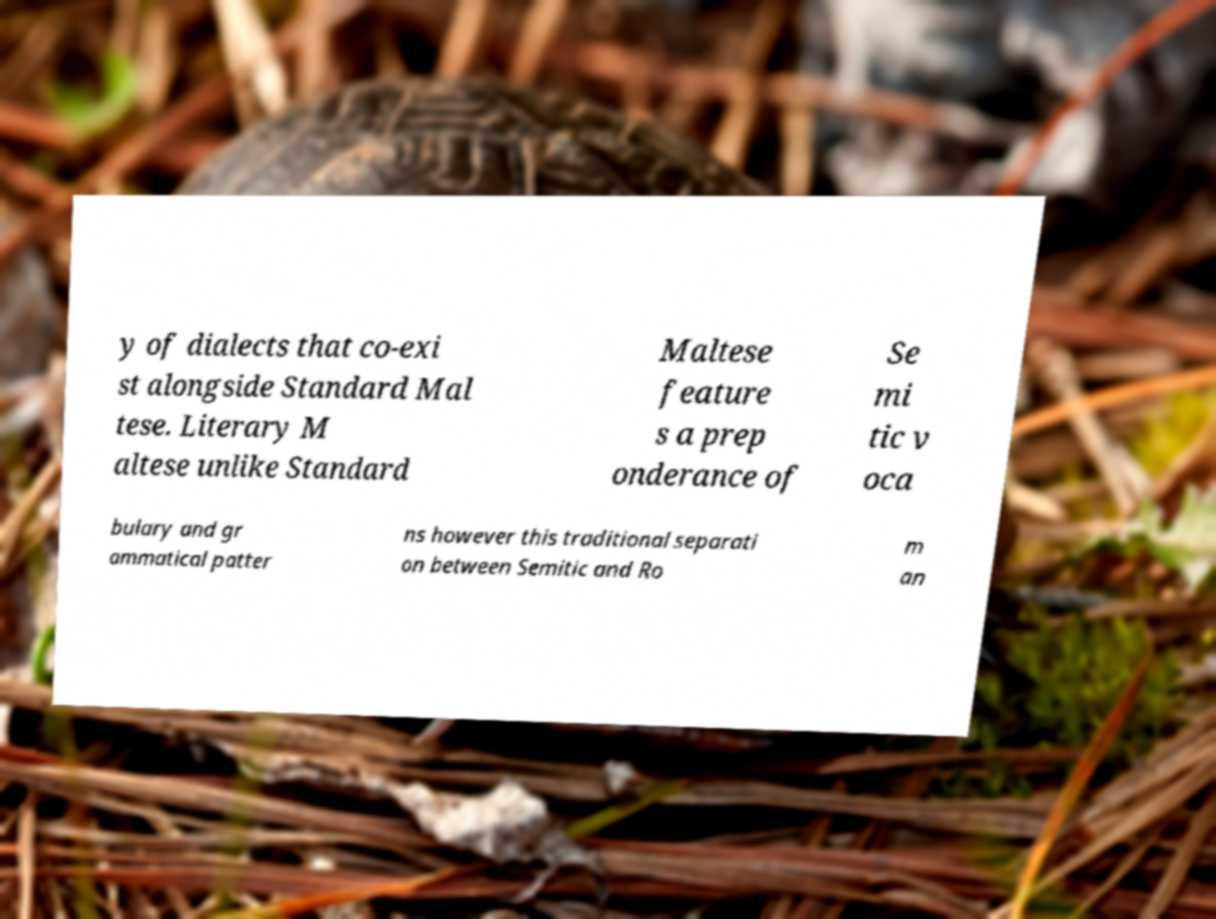For documentation purposes, I need the text within this image transcribed. Could you provide that? y of dialects that co-exi st alongside Standard Mal tese. Literary M altese unlike Standard Maltese feature s a prep onderance of Se mi tic v oca bulary and gr ammatical patter ns however this traditional separati on between Semitic and Ro m an 